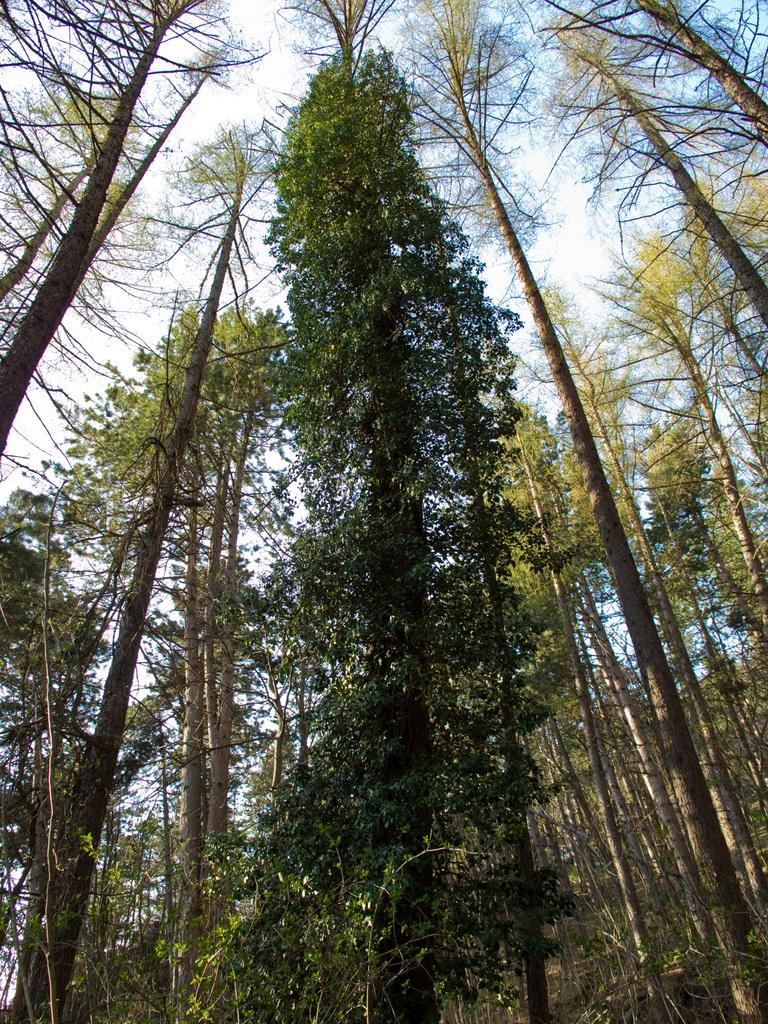What type of vegetation is present in the image? There are many trees in the image. How tall are the trees in the image? The trees are tall. What is visible at the top of the image? The sky is visible at the top of the image. What type of sidewalk can be seen near the trees in the image? There is no sidewalk present in the image; it features tall trees and a visible sky. 